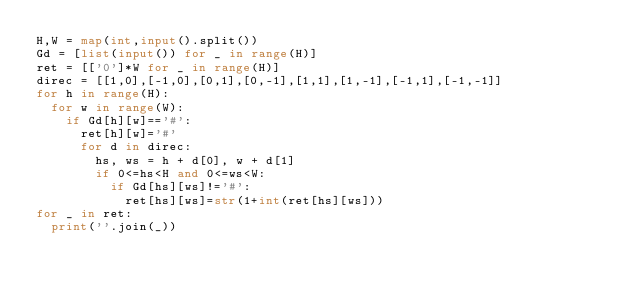Convert code to text. <code><loc_0><loc_0><loc_500><loc_500><_Python_>H,W = map(int,input().split())
Gd = [list(input()) for _ in range(H)]
ret = [['0']*W for _ in range(H)]
direc = [[1,0],[-1,0],[0,1],[0,-1],[1,1],[1,-1],[-1,1],[-1,-1]]
for h in range(H):
  for w in range(W):
    if Gd[h][w]=='#':
      ret[h][w]='#'
      for d in direc:
        hs, ws = h + d[0], w + d[1]
        if 0<=hs<H and 0<=ws<W:
          if Gd[hs][ws]!='#':
            ret[hs][ws]=str(1+int(ret[hs][ws]))
for _ in ret:
  print(''.join(_))</code> 